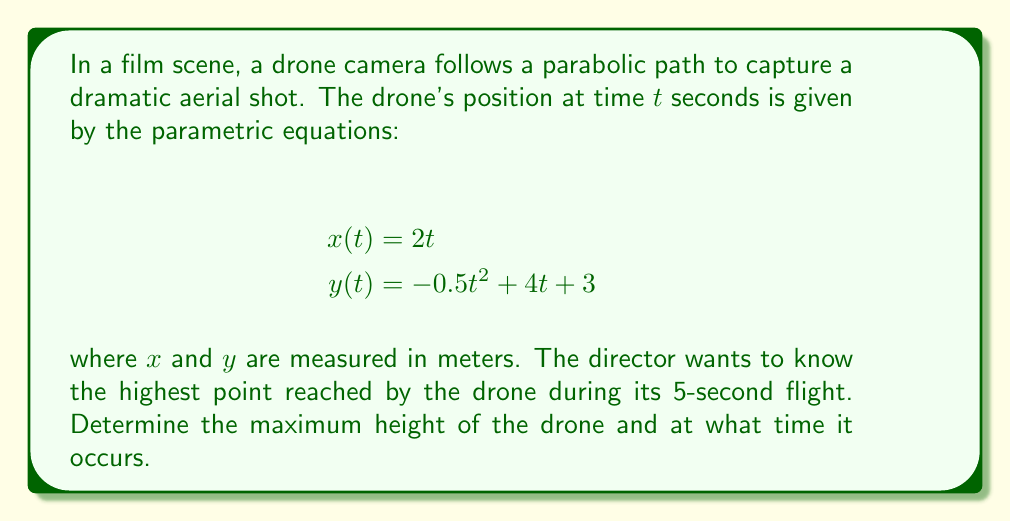Provide a solution to this math problem. To solve this problem, we'll follow these steps:

1) The drone's vertical position is given by $y(t) = -0.5t^2 + 4t + 3$. This is a quadratic function, and its graph is a parabola.

2) The highest point of a parabola occurs at its vertex. For a quadratic function in the form $y = at^2 + bt + c$, the t-coordinate of the vertex is given by $t = -\frac{b}{2a}$.

3) In our case, $a = -0.5$, $b = 4$, and $c = 3$. Let's calculate the time at which the drone reaches its highest point:

   $t = -\frac{b}{2a} = -\frac{4}{2(-0.5)} = -\frac{4}{-1} = 4$ seconds

4) To find the maximum height, we substitute $t = 4$ into the equation for $y(t)$:

   $y(4) = -0.5(4)^2 + 4(4) + 3$
         $= -0.5(16) + 16 + 3$
         $= -8 + 16 + 3$
         $= 11$ meters

5) We should verify that this occurs within the 5-second flight time, which it does.

Therefore, the drone reaches its maximum height of 11 meters at t = 4 seconds.
Answer: The drone reaches its maximum height of 11 meters at t = 4 seconds. 